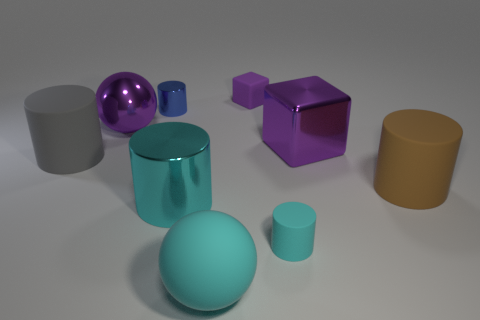Subtract all brown matte cylinders. How many cylinders are left? 4 Subtract all gray cylinders. How many cylinders are left? 4 Subtract 1 cylinders. How many cylinders are left? 4 Subtract all yellow cylinders. Subtract all green cubes. How many cylinders are left? 5 Add 1 big gray things. How many objects exist? 10 Subtract all spheres. How many objects are left? 7 Add 9 large yellow matte objects. How many large yellow matte objects exist? 9 Subtract 1 gray cylinders. How many objects are left? 8 Subtract all tiny blue matte balls. Subtract all purple cubes. How many objects are left? 7 Add 3 shiny blocks. How many shiny blocks are left? 4 